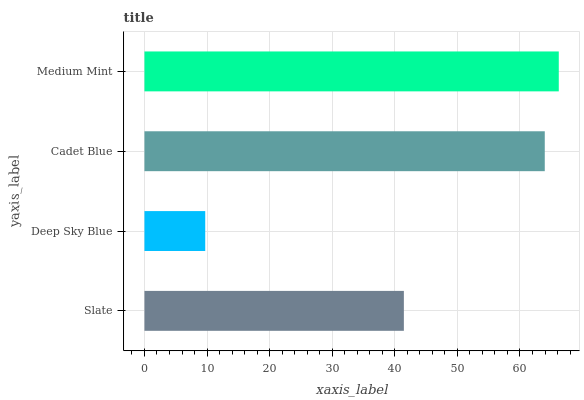Is Deep Sky Blue the minimum?
Answer yes or no. Yes. Is Medium Mint the maximum?
Answer yes or no. Yes. Is Cadet Blue the minimum?
Answer yes or no. No. Is Cadet Blue the maximum?
Answer yes or no. No. Is Cadet Blue greater than Deep Sky Blue?
Answer yes or no. Yes. Is Deep Sky Blue less than Cadet Blue?
Answer yes or no. Yes. Is Deep Sky Blue greater than Cadet Blue?
Answer yes or no. No. Is Cadet Blue less than Deep Sky Blue?
Answer yes or no. No. Is Cadet Blue the high median?
Answer yes or no. Yes. Is Slate the low median?
Answer yes or no. Yes. Is Slate the high median?
Answer yes or no. No. Is Deep Sky Blue the low median?
Answer yes or no. No. 